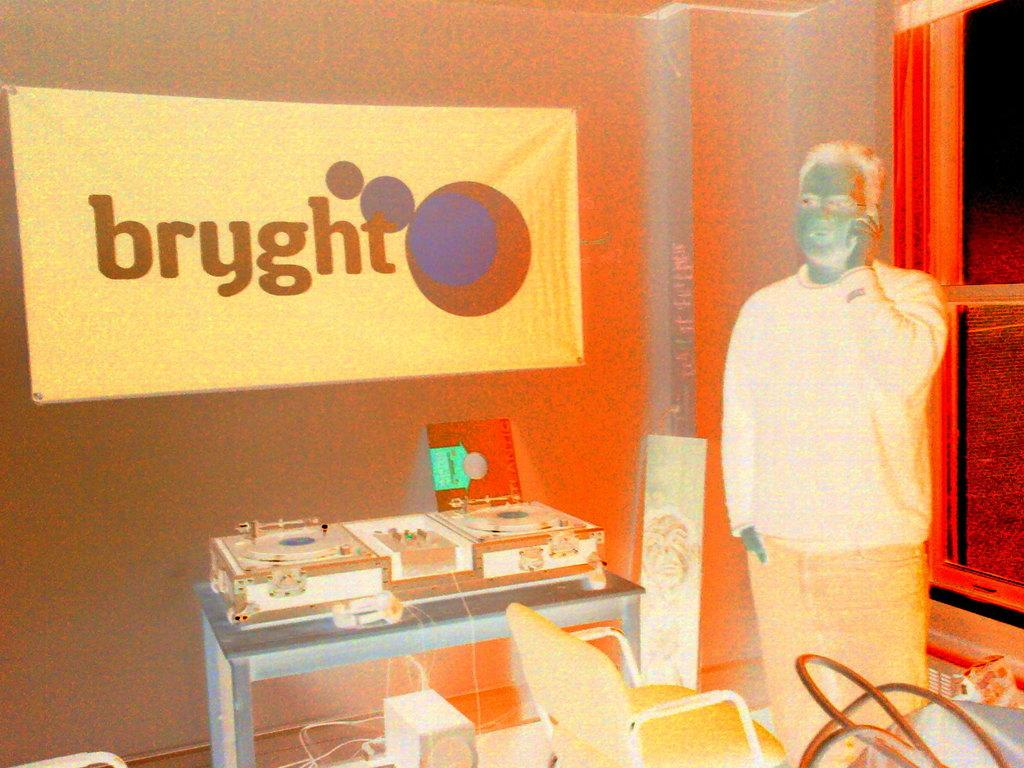Who or what is present in the image? There is a person in the image. What can be seen hanging or displayed in the image? There is a banner in the image. What type of furniture is visible in the image? There is a table and a chair in the image. What architectural feature is present in the image? There is a window in the image. What else can be seen in the image besides the person, banner, table, chair, and window? There are objects in the image. What type of brick is used to construct the system in the image? There is no system or brick present in the image. 